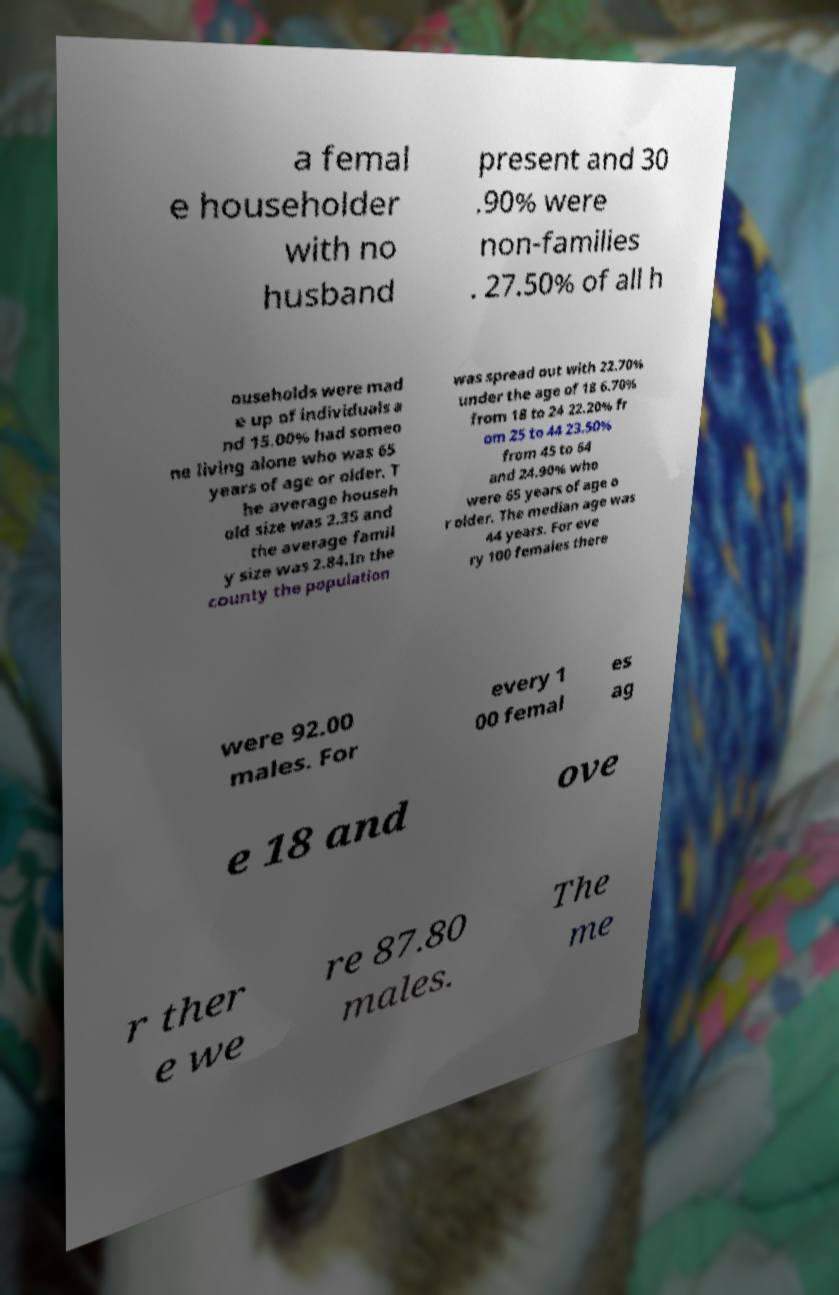Can you accurately transcribe the text from the provided image for me? a femal e householder with no husband present and 30 .90% were non-families . 27.50% of all h ouseholds were mad e up of individuals a nd 15.00% had someo ne living alone who was 65 years of age or older. T he average househ old size was 2.35 and the average famil y size was 2.84.In the county the population was spread out with 22.70% under the age of 18 6.70% from 18 to 24 22.20% fr om 25 to 44 23.50% from 45 to 64 and 24.90% who were 65 years of age o r older. The median age was 44 years. For eve ry 100 females there were 92.00 males. For every 1 00 femal es ag e 18 and ove r ther e we re 87.80 males. The me 